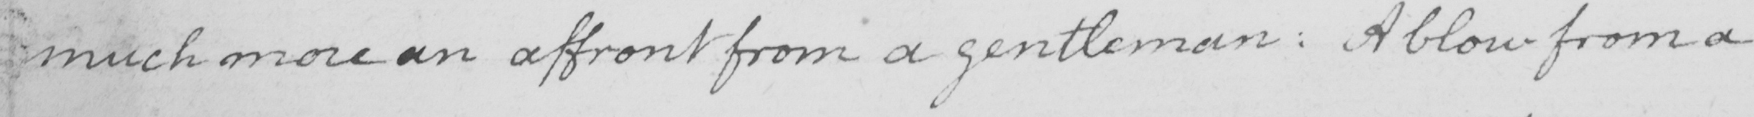Transcribe the text shown in this historical manuscript line. much more an affront from a gentleman :  A blow from a 